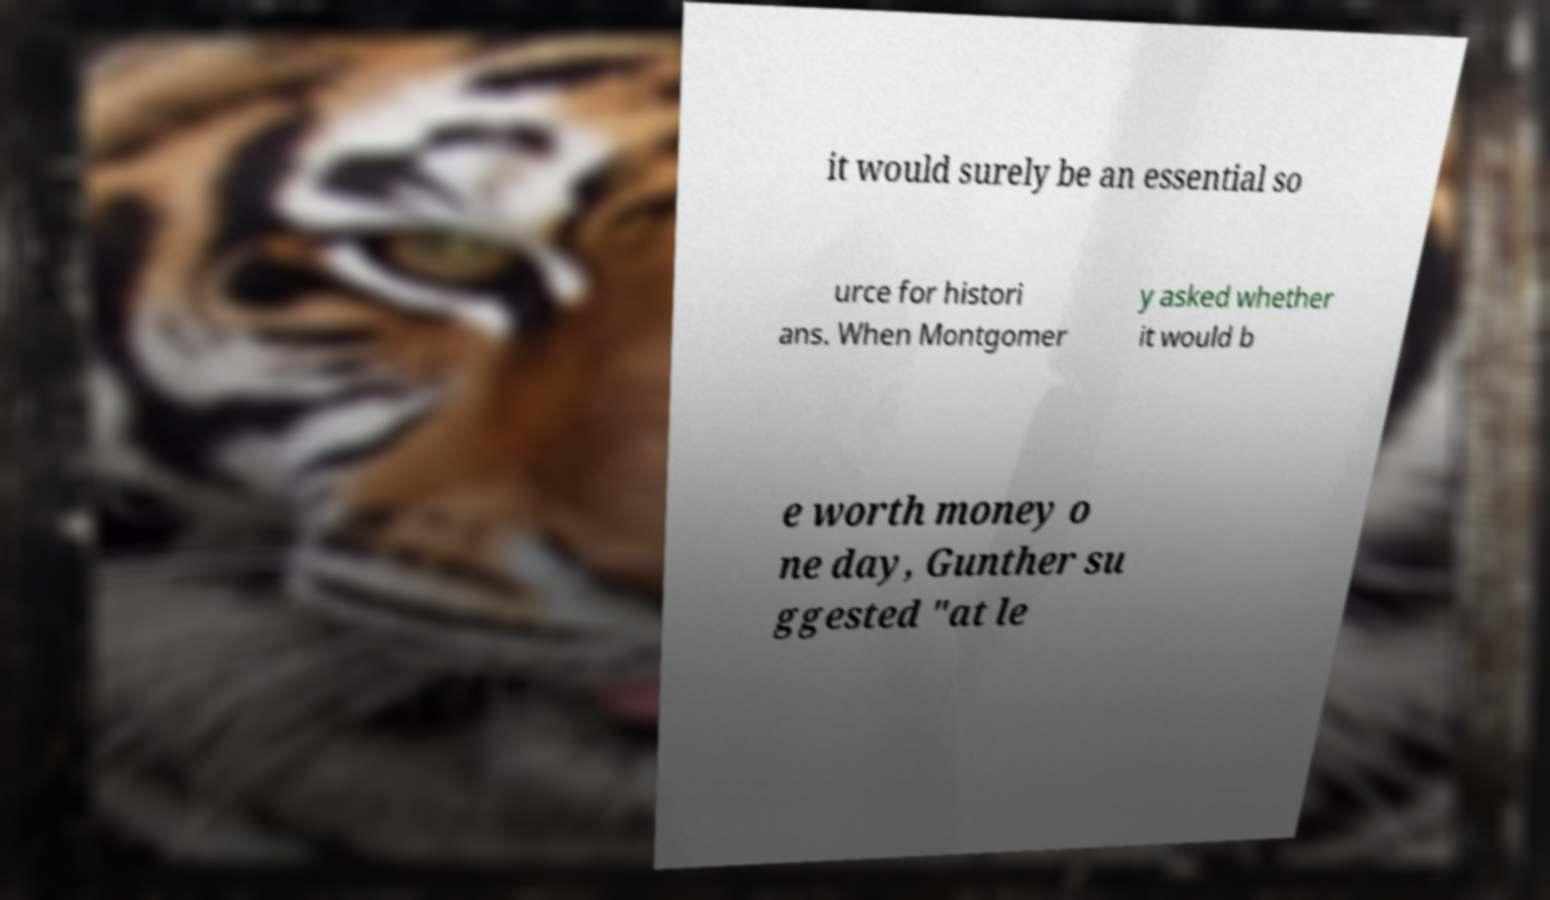Could you extract and type out the text from this image? it would surely be an essential so urce for histori ans. When Montgomer y asked whether it would b e worth money o ne day, Gunther su ggested "at le 